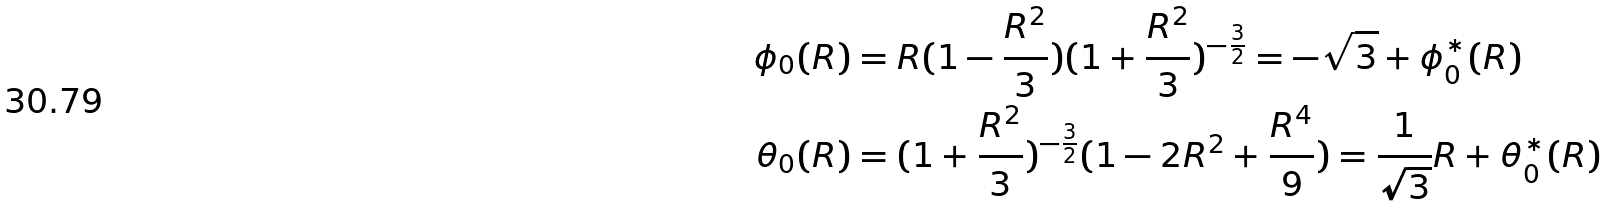<formula> <loc_0><loc_0><loc_500><loc_500>\phi _ { 0 } ( R ) & = R ( 1 - \frac { R ^ { 2 } } { 3 } ) ( 1 + \frac { R ^ { 2 } } { 3 } ) ^ { - \frac { 3 } { 2 } } = - \sqrt { 3 } + \phi _ { 0 } ^ { * } ( R ) \\ \theta _ { 0 } ( R ) & = ( 1 + \frac { R ^ { 2 } } { 3 } ) ^ { - \frac { 3 } { 2 } } ( 1 - 2 R ^ { 2 } + \frac { R ^ { 4 } } { 9 } ) = \frac { 1 } { \sqrt { 3 } } R + \theta _ { 0 } ^ { * } ( R )</formula> 